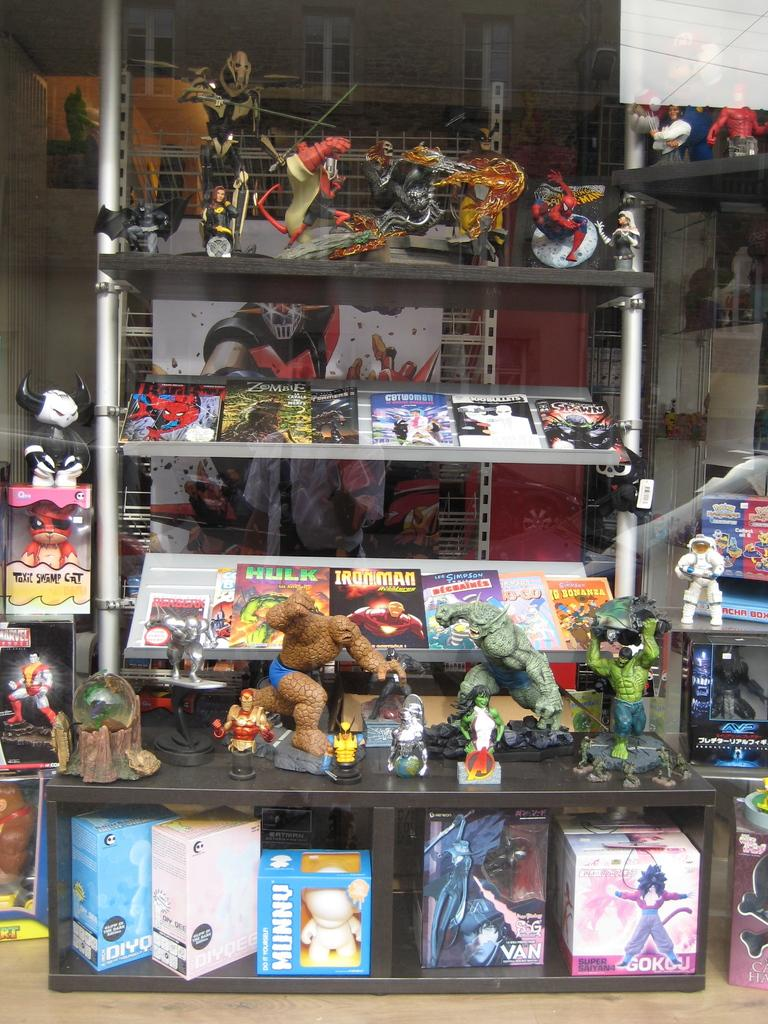<image>
Describe the image concisely. Superhero toys displayed on a shelf along with Hulk, Ironman, Catwoman, and Zombie books. 